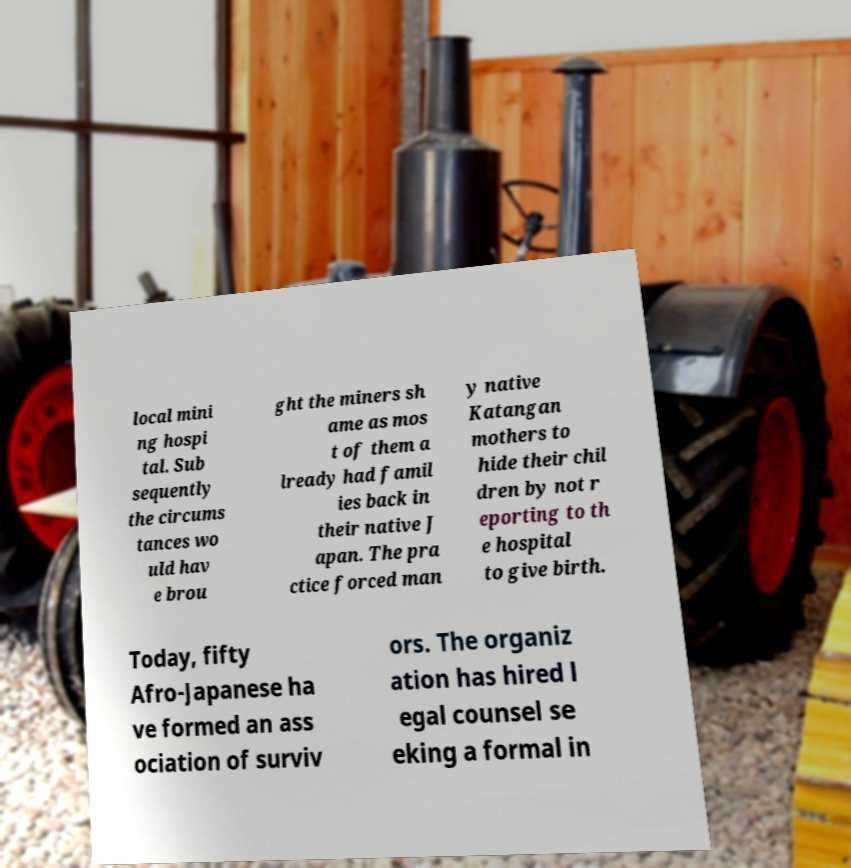Could you extract and type out the text from this image? local mini ng hospi tal. Sub sequently the circums tances wo uld hav e brou ght the miners sh ame as mos t of them a lready had famil ies back in their native J apan. The pra ctice forced man y native Katangan mothers to hide their chil dren by not r eporting to th e hospital to give birth. Today, fifty Afro-Japanese ha ve formed an ass ociation of surviv ors. The organiz ation has hired l egal counsel se eking a formal in 